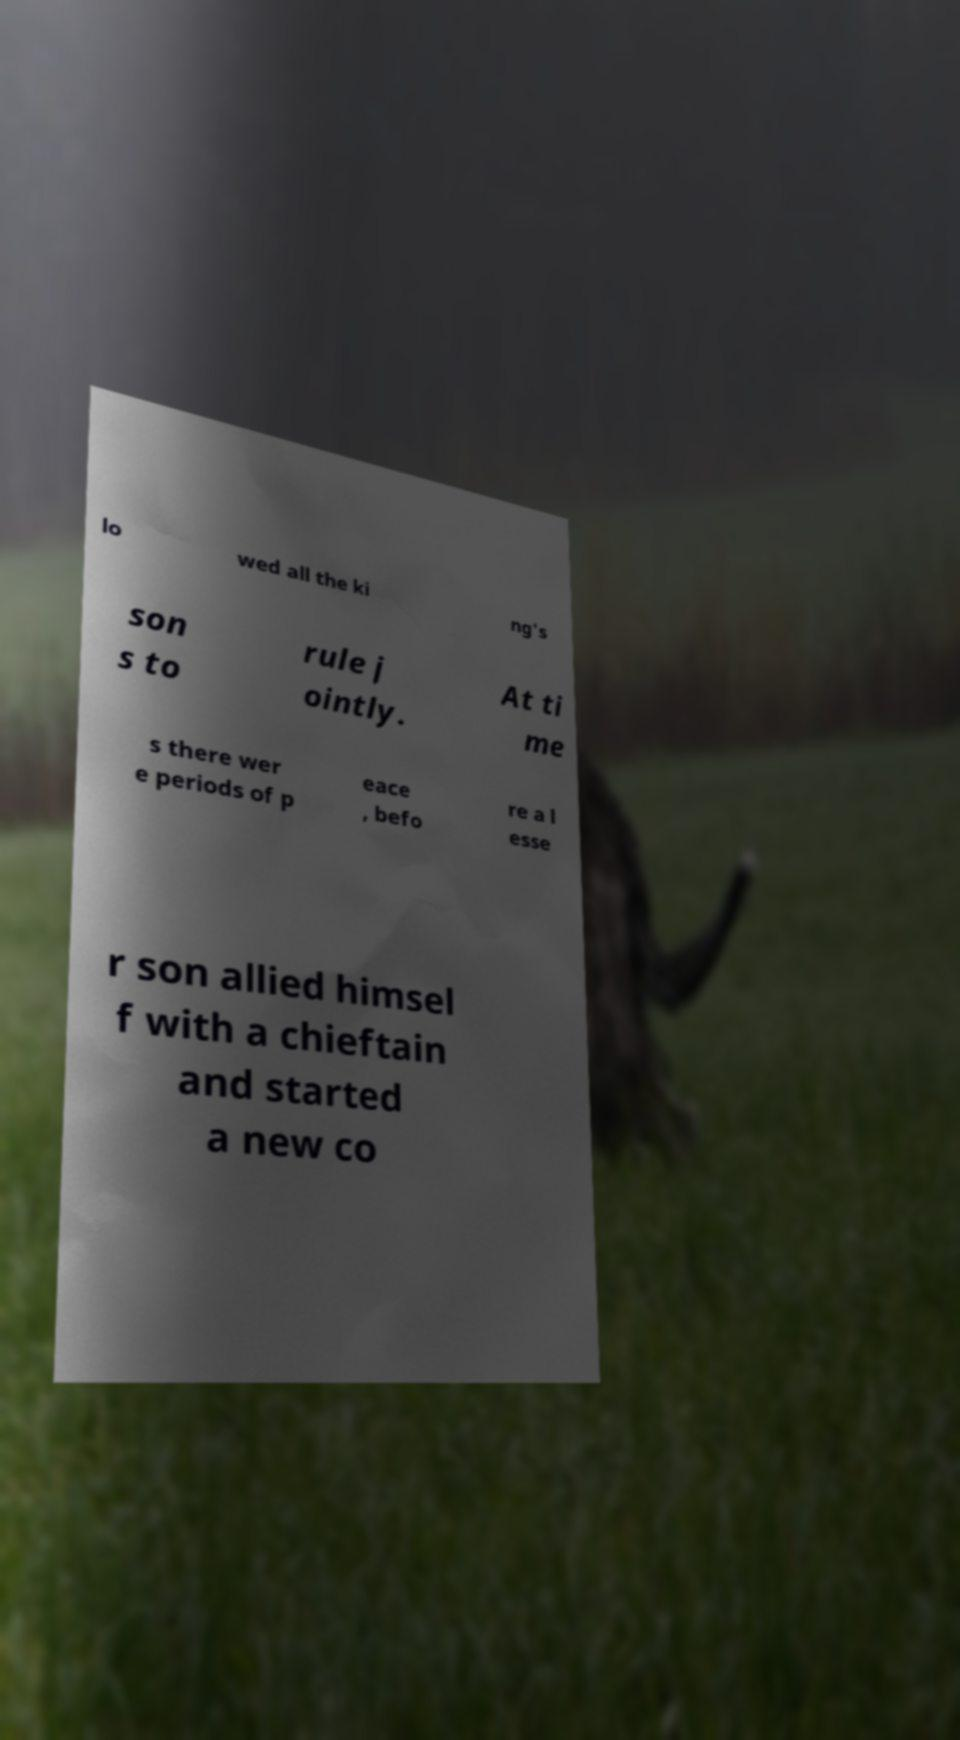Please identify and transcribe the text found in this image. lo wed all the ki ng's son s to rule j ointly. At ti me s there wer e periods of p eace , befo re a l esse r son allied himsel f with a chieftain and started a new co 